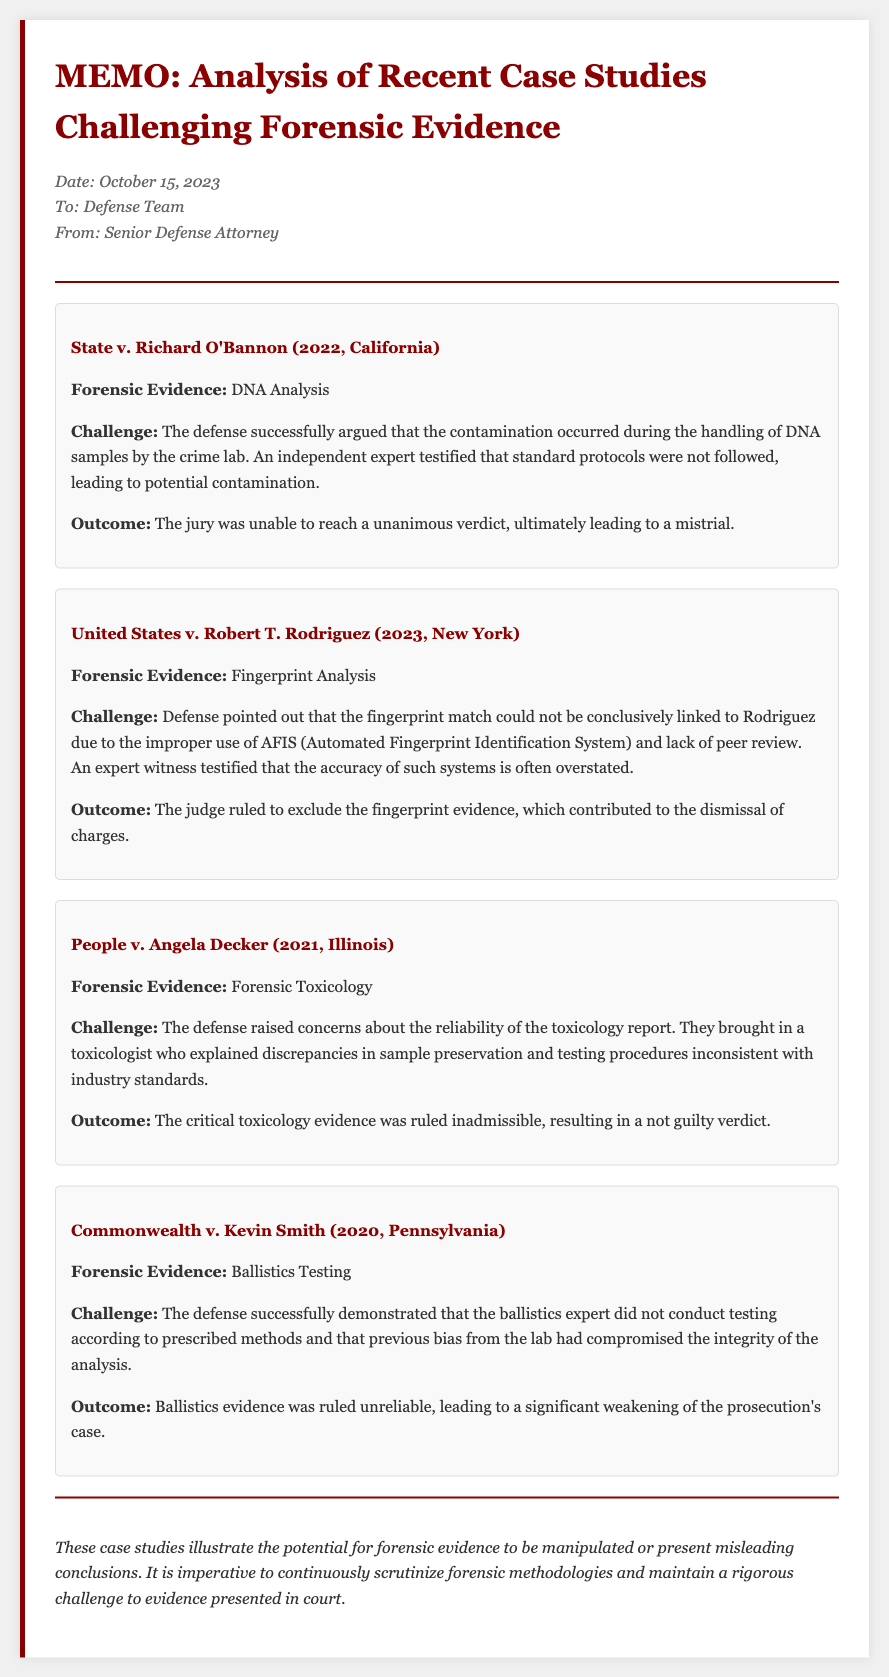What is the date of the memo? The date of the memo is explicitly stated at the top of the document.
Answer: October 15, 2023 Who is the memo addressed to? The memo specifies the recipient under the "To" section.
Answer: Defense Team What forensic evidence was challenged in the case of Richard O'Bannon? The specific type of forensic evidence is listed in the summary of the case.
Answer: DNA Analysis What was the outcome of the Commonwealth v. Kevin Smith? The outcome is provided in each case study detailing the results.
Answer: Significant weakening of the prosecution's case What criticism was raised regarding the fingerprint evidence in United States v. Robert T. Rodriguez? The document describes issues with the evidence, detailing reasons for the challenge.
Answer: Improper use of AFIS How many case studies are analyzed in the memo? The total number of case studies is mentioned in the document structure.
Answer: Four Who testified about the discrepancies in sample preservation for People v. Angela Decker? The document highlights the expert contributors involved in the cases.
Answer: A toxicologist What year did the case of Commonwealth v. Kevin Smith take place? The year is specified alongside the case name in the document.
Answer: 2020 